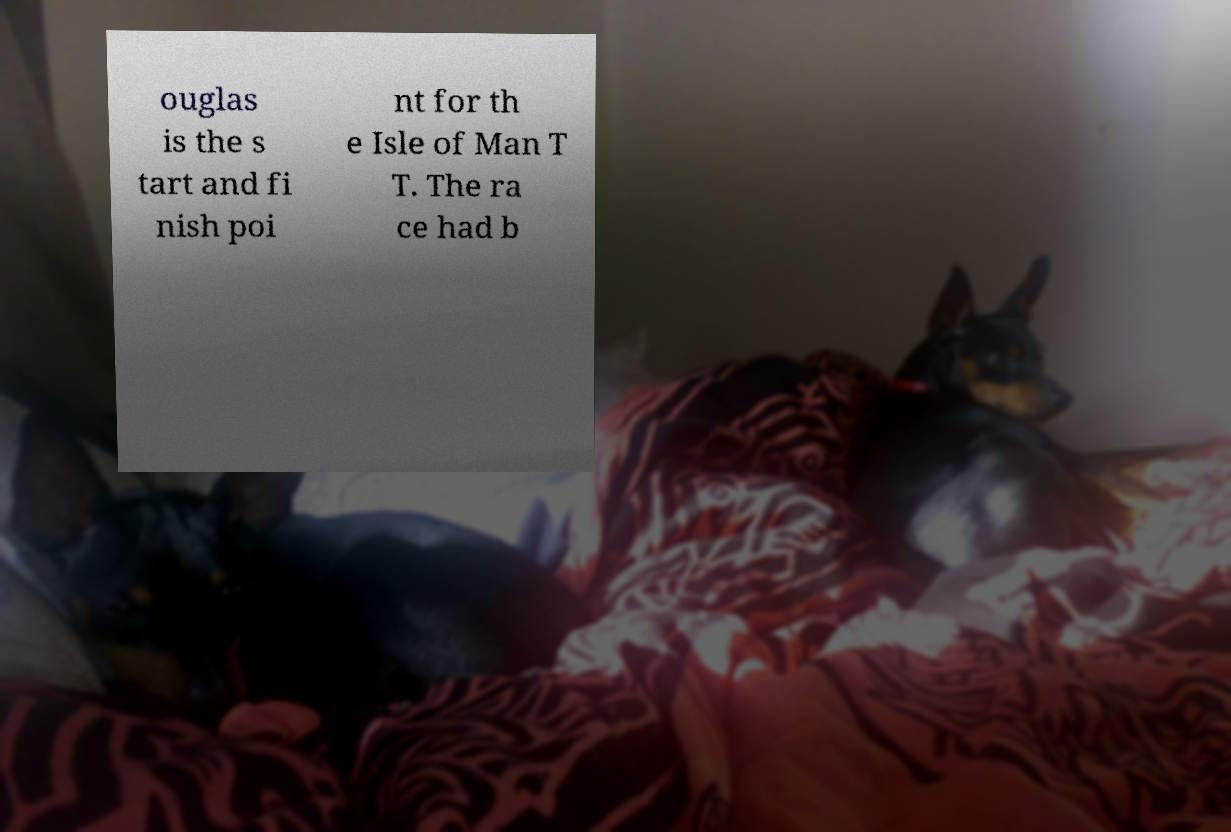There's text embedded in this image that I need extracted. Can you transcribe it verbatim? ouglas is the s tart and fi nish poi nt for th e Isle of Man T T. The ra ce had b 